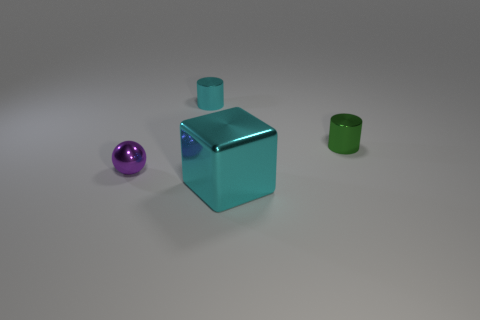Add 1 big cyan shiny cylinders. How many objects exist? 5 Subtract all spheres. How many objects are left? 3 Add 4 big brown cylinders. How many big brown cylinders exist? 4 Subtract 0 purple cylinders. How many objects are left? 4 Subtract all purple metal things. Subtract all shiny cubes. How many objects are left? 2 Add 4 small cyan cylinders. How many small cyan cylinders are left? 5 